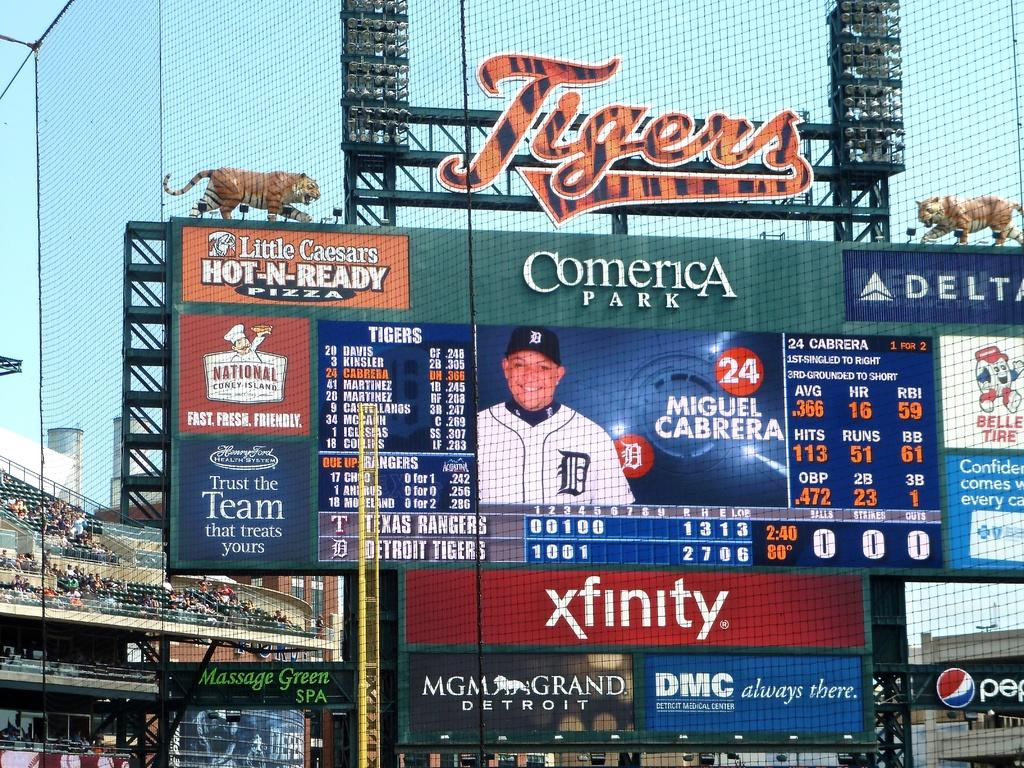<image>
Write a terse but informative summary of the picture. A large screen display for the Tigers at Comerica Park stadium 